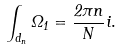Convert formula to latex. <formula><loc_0><loc_0><loc_500><loc_500>\int _ { d _ { n } } \Omega _ { 1 } = \frac { 2 \pi n } { N } i .</formula> 